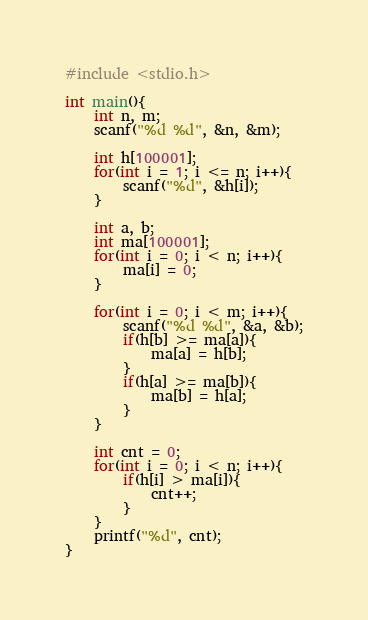<code> <loc_0><loc_0><loc_500><loc_500><_C_>#include <stdio.h>

int main(){
    int n, m;
    scanf("%d %d", &n, &m);

    int h[100001];
    for(int i = 1; i <= n; i++){
        scanf("%d", &h[i]);
    }

    int a, b;
    int ma[100001];
    for(int i = 0; i < n; i++){
        ma[i] = 0;
    }

    for(int i = 0; i < m; i++){
        scanf("%d %d", &a, &b);
        if(h[b] >= ma[a]){
            ma[a] = h[b];
        }
        if(h[a] >= ma[b]){
            ma[b] = h[a];
        }
    }

    int cnt = 0;
    for(int i = 0; i < n; i++){
        if(h[i] > ma[i]){
            cnt++;
        }
    }
    printf("%d", cnt);
}</code> 